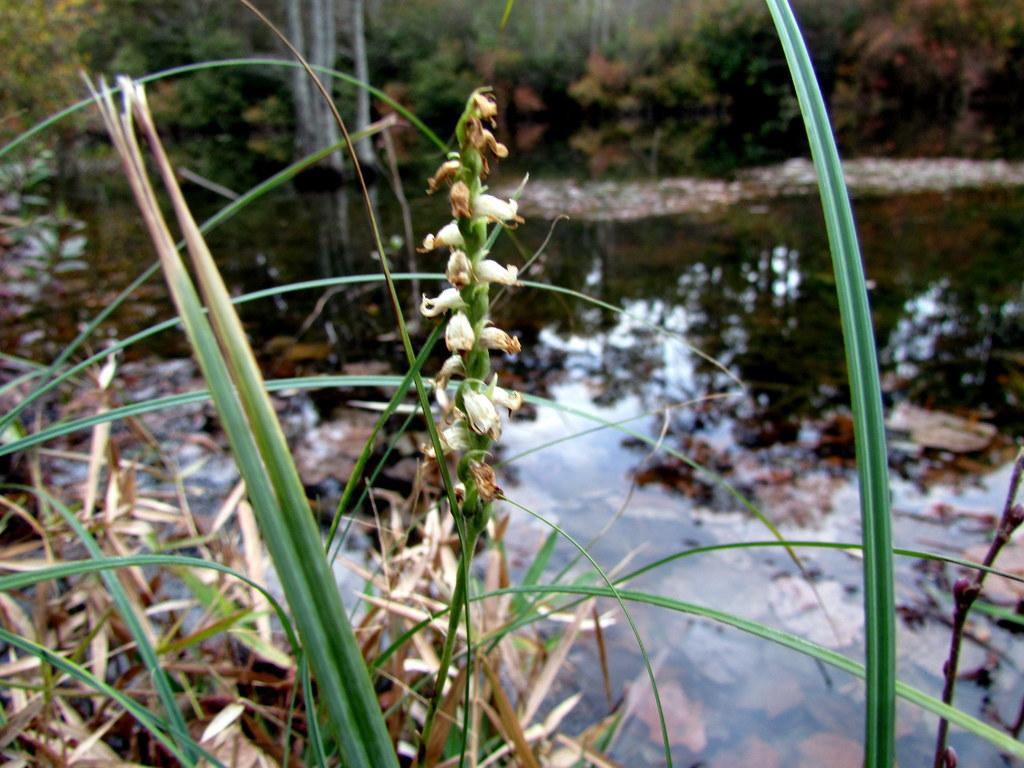What type of vegetation can be seen in the image? There is dry grass and flowers in the image. Where are the grass and flowers located in relation to a body of water? The grass and flowers are near a lake in the image. What other types of plant life can be seen in the image? Trees and bushes are present in the image. What type of ant can be seen carrying a bottle in the image? There are no ants or bottles present in the image. What type of plough is being used to cultivate the dry grass in the image? There is no plough present in the image, as it is a natural landscape with dry grass, flowers, and a lake. 